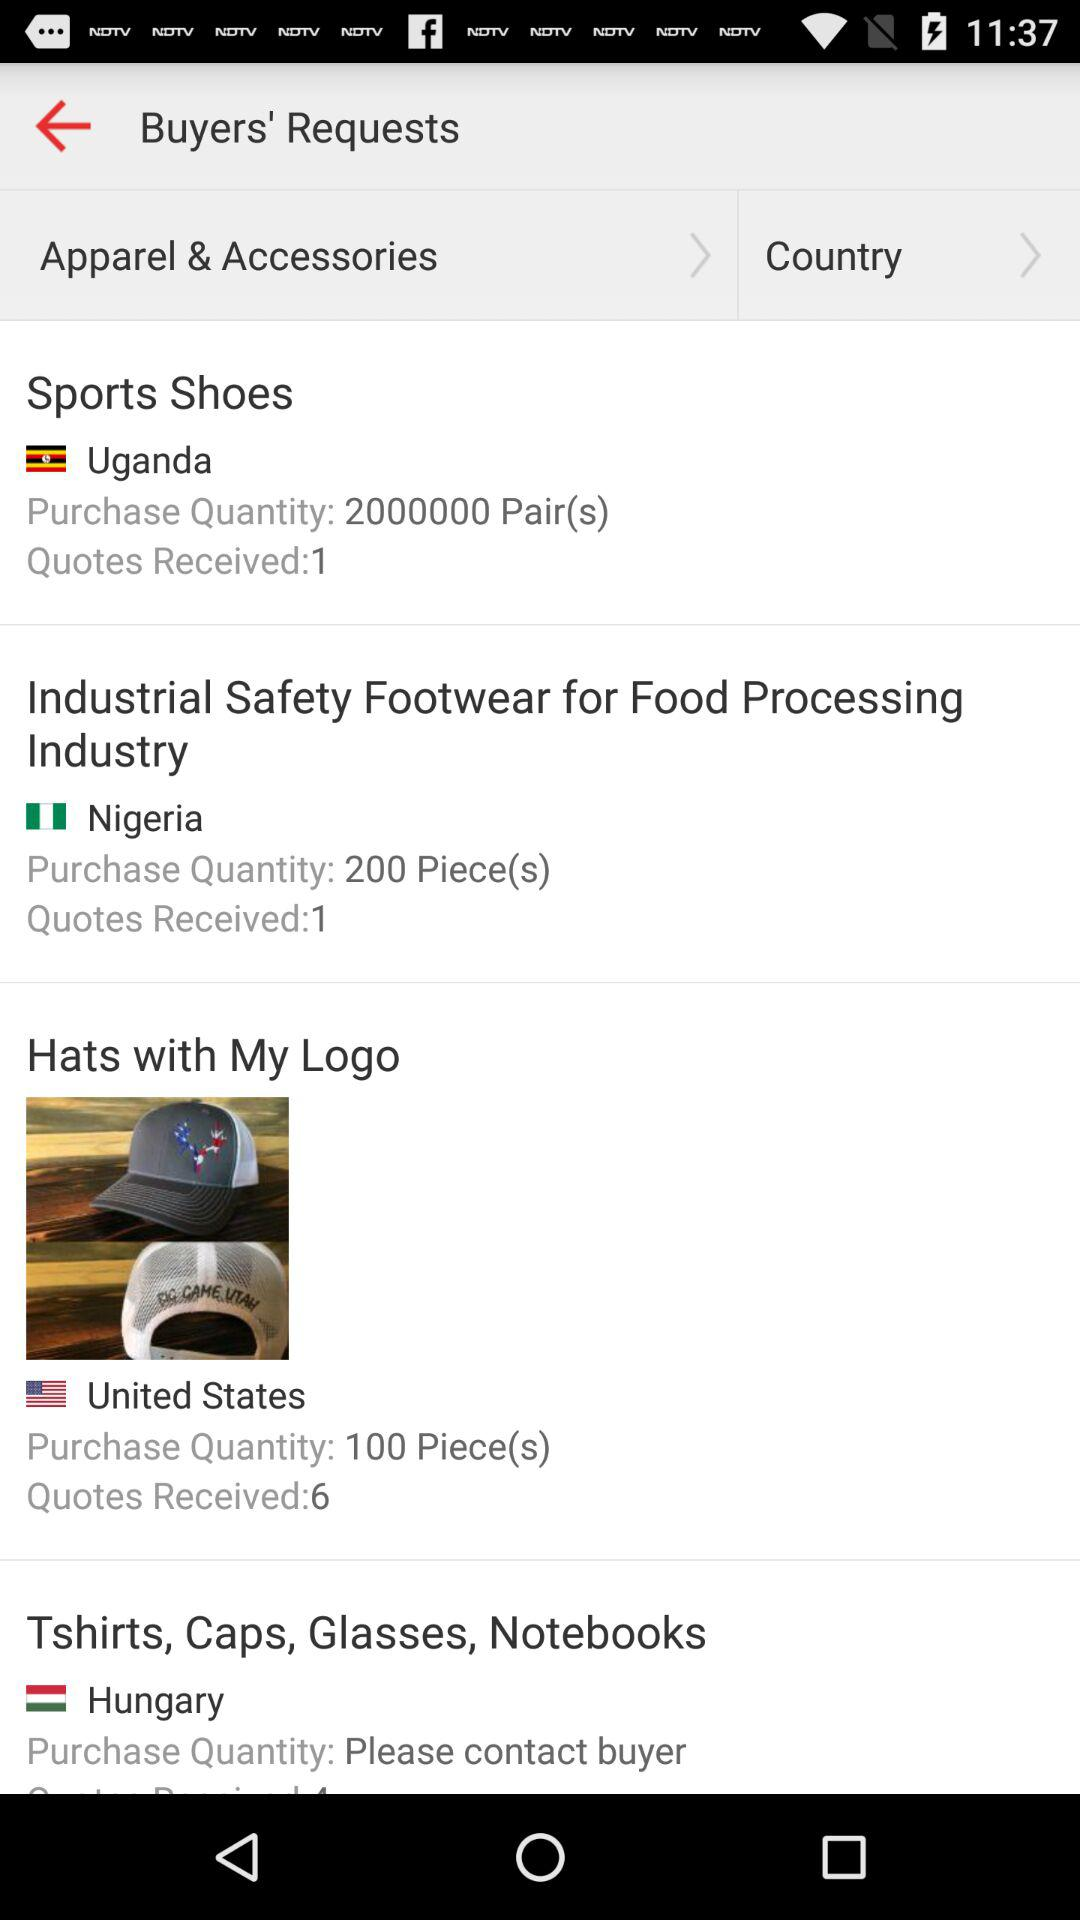How many quotes have been received for the request with the most quotes?
Answer the question using a single word or phrase. 6 